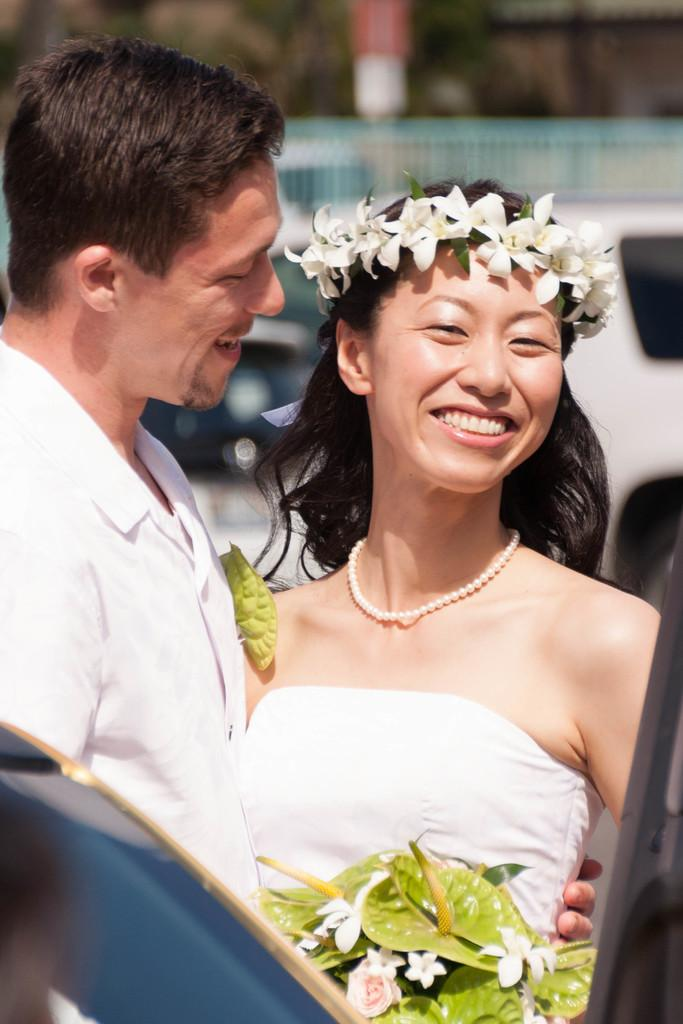How many people are present in the image? There are two people, a man and a woman, present in the image. What expressions do the people in the image have? Both the man and the woman are smiling in the image. What can be seen in the background of the image? There are vehicles and a fence in the background of the image. What is the quality of the image? The image is blurry. What ideas do the kittens have about the property in the image? There are no kittens present in the image, so it is not possible to determine their ideas about the property. 